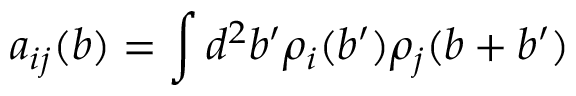<formula> <loc_0><loc_0><loc_500><loc_500>a _ { i j } ( b ) = \int d ^ { 2 } b ^ { \prime } \rho _ { i } ( b ^ { \prime } ) \rho _ { j } ( b + b ^ { \prime } )</formula> 